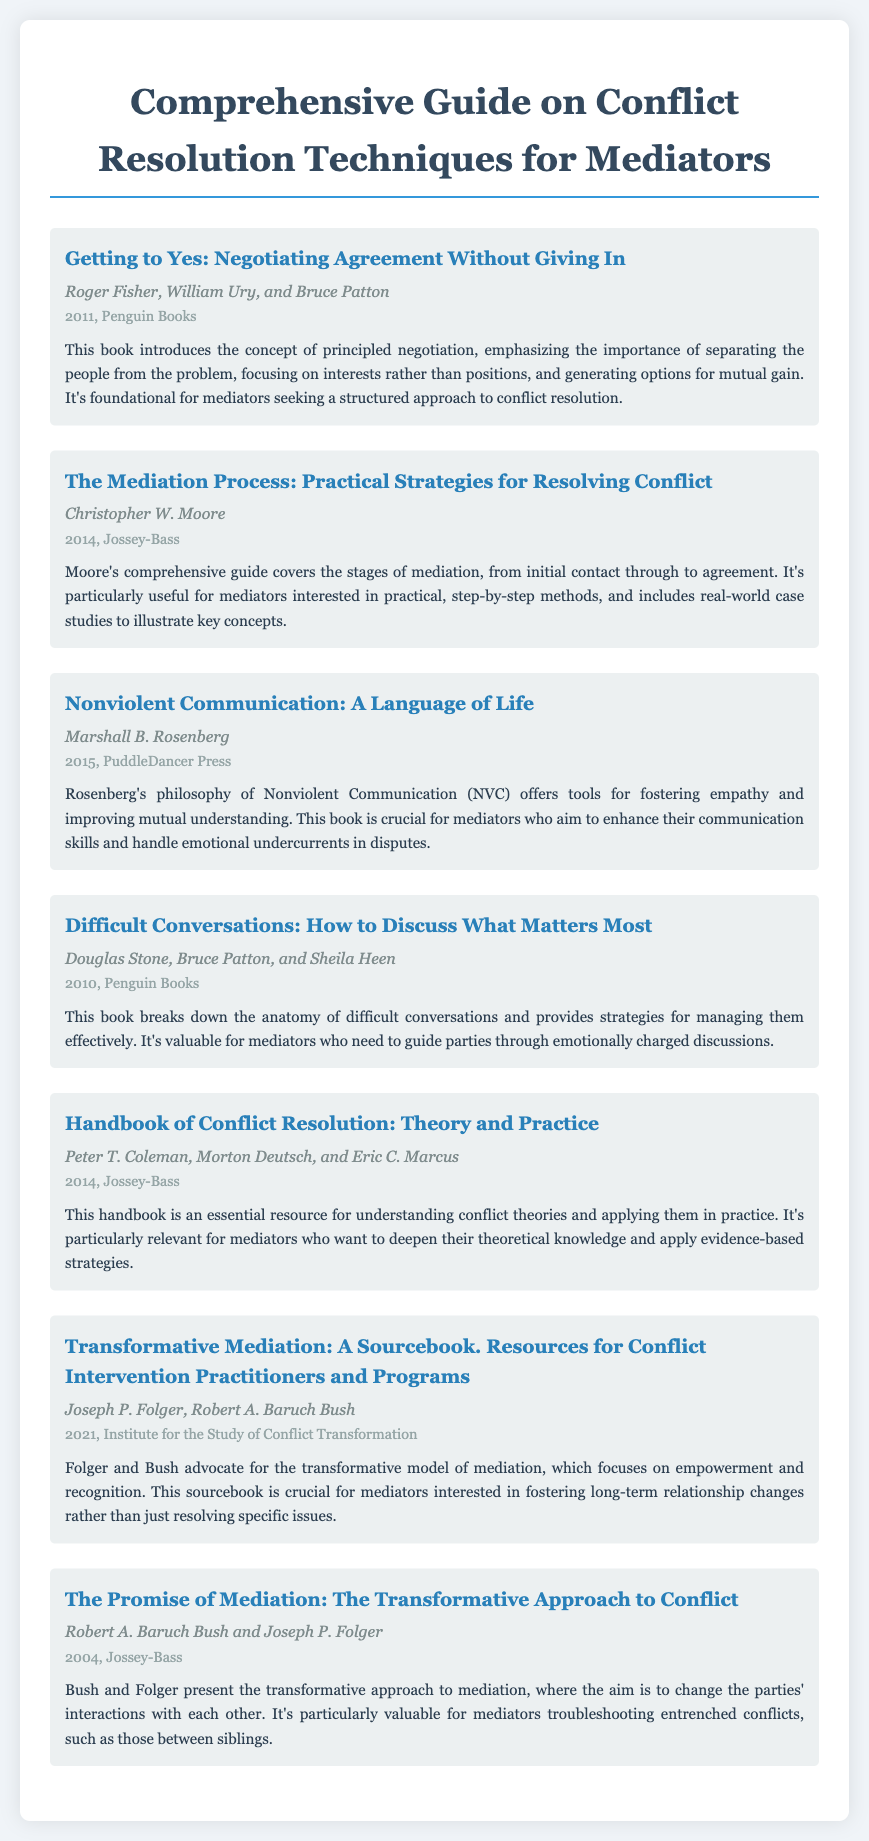what is the title of the first book? The title of the first book is mentioned in the document as "Getting to Yes: Negotiating Agreement Without Giving In."
Answer: Getting to Yes: Negotiating Agreement Without Giving In who are the authors of "Nonviolent Communication: A Language of Life"? The authors of "Nonviolent Communication: A Language of Life" are specified in the document.
Answer: Marshall B. Rosenberg in what year was "The Promise of Mediation: The Transformative Approach to Conflict" published? The publication year of "The Promise of Mediation: The Transformative Approach to Conflict" is detailed in the document.
Answer: 2004 how many books have been authored by Roger Fisher? The document lists one book authored by Roger Fisher, which is indicated at the beginning of the bibliography.
Answer: One what is a key concept introduced in "Getting to Yes"? The concept emphasized in "Getting to Yes" is highlighted in the summary.
Answer: Principled negotiation which book focuses on enhancing communication skills? The document specifies that "Nonviolent Communication: A Language of Life" is crucial for improving communication skills.
Answer: Nonviolent Communication: A Language of Life who are the authors of "Transformative Mediation: A Sourcebook"? The authors of "Transformative Mediation: A Sourcebook" are stated in the bibliography.
Answer: Joseph P. Folger, Robert A. Baruch Bush what is the primary focus of transformative mediation? The document describes the focus of transformative mediation as empowerment and recognition.
Answer: Empowerment and recognition 